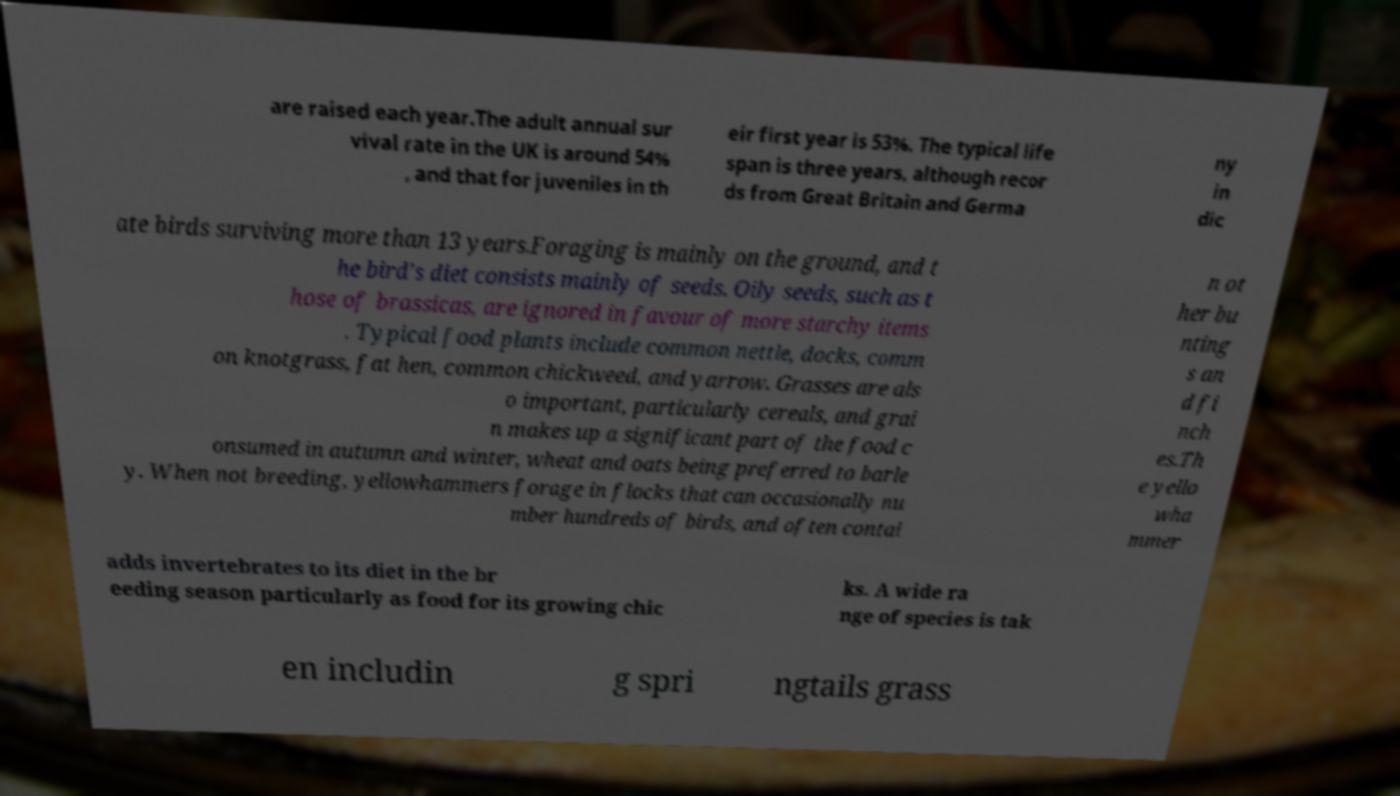Could you assist in decoding the text presented in this image and type it out clearly? are raised each year.The adult annual sur vival rate in the UK is around 54% , and that for juveniles in th eir first year is 53%. The typical life span is three years, although recor ds from Great Britain and Germa ny in dic ate birds surviving more than 13 years.Foraging is mainly on the ground, and t he bird's diet consists mainly of seeds. Oily seeds, such as t hose of brassicas, are ignored in favour of more starchy items . Typical food plants include common nettle, docks, comm on knotgrass, fat hen, common chickweed, and yarrow. Grasses are als o important, particularly cereals, and grai n makes up a significant part of the food c onsumed in autumn and winter, wheat and oats being preferred to barle y. When not breeding, yellowhammers forage in flocks that can occasionally nu mber hundreds of birds, and often contai n ot her bu nting s an d fi nch es.Th e yello wha mmer adds invertebrates to its diet in the br eeding season particularly as food for its growing chic ks. A wide ra nge of species is tak en includin g spri ngtails grass 